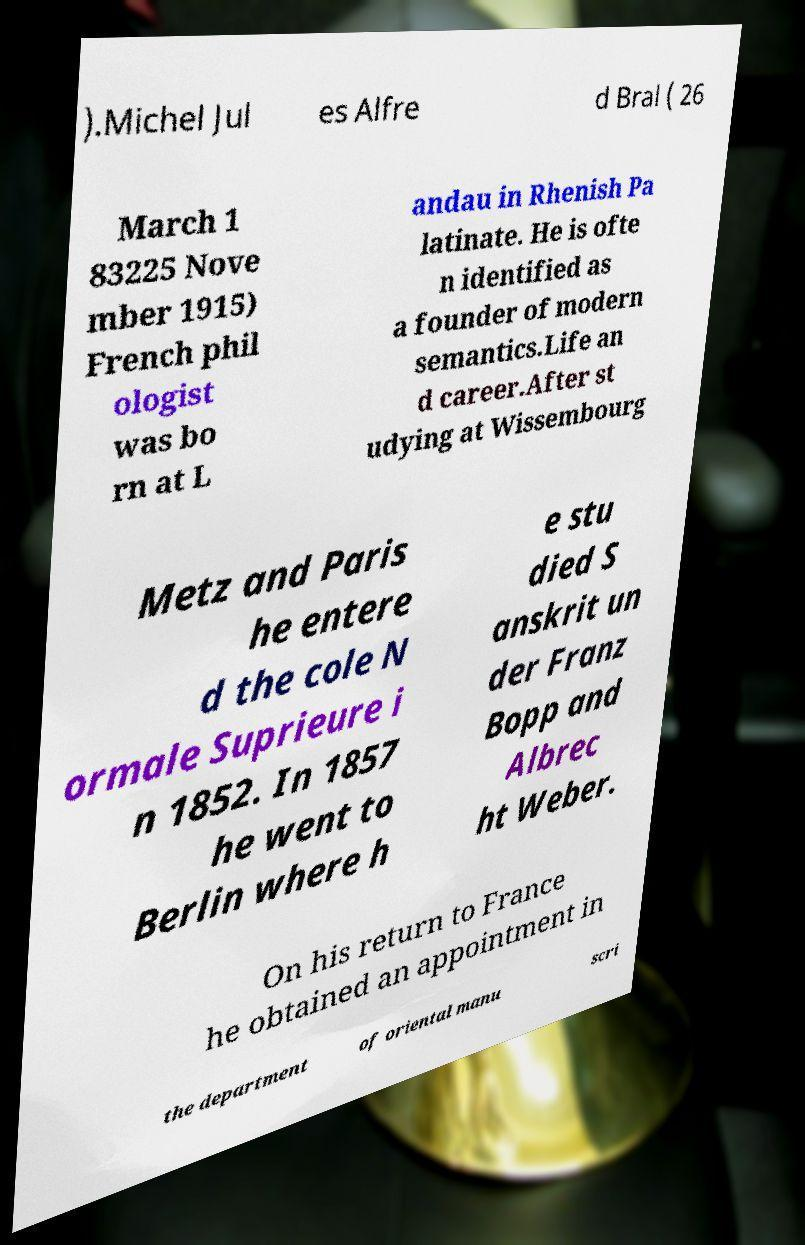Could you extract and type out the text from this image? ).Michel Jul es Alfre d Bral ( 26 March 1 83225 Nove mber 1915) French phil ologist was bo rn at L andau in Rhenish Pa latinate. He is ofte n identified as a founder of modern semantics.Life an d career.After st udying at Wissembourg Metz and Paris he entere d the cole N ormale Suprieure i n 1852. In 1857 he went to Berlin where h e stu died S anskrit un der Franz Bopp and Albrec ht Weber. On his return to France he obtained an appointment in the department of oriental manu scri 